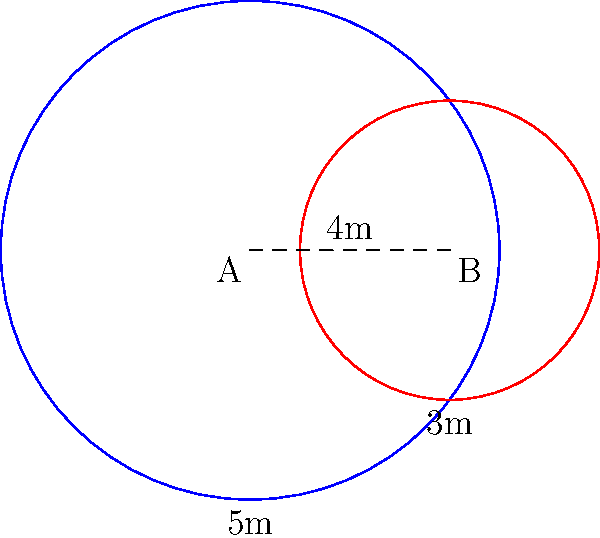During a spacewalk, two circular safety zones are established for different activities. Zone A has a radius of 5 meters, and Zone B has a radius of 3 meters. The centers of these zones are 4 meters apart. Calculate the area of the overlapping region between these two safety zones. Round your answer to two decimal places. To find the area of overlap between two circles, we can use the following steps:

1) First, we need to calculate the distance $d$ between the centers of the circles. We're given that $d = 4$ meters.

2) Let's denote the radii as $r_1 = 5$ m and $r_2 = 3$ m.

3) To find the area of overlap, we use the formula:

   $$A = r_1^2 \arccos(\frac{d^2 + r_1^2 - r_2^2}{2dr_1}) + r_2^2 \arccos(\frac{d^2 + r_2^2 - r_1^2}{2dr_2}) - \frac{1}{2}\sqrt{(-d+r_1+r_2)(d+r_1-r_2)(d-r_1+r_2)(d+r_1+r_2)}$$

4) Substituting our values:

   $$A = 5^2 \arccos(\frac{4^2 + 5^2 - 3^2}{2 \cdot 4 \cdot 5}) + 3^2 \arccos(\frac{4^2 + 3^2 - 5^2}{2 \cdot 4 \cdot 3}) - \frac{1}{2}\sqrt{(-4+5+3)(4+5-3)(4-5+3)(4+5+3)}$$

5) Simplifying:

   $$A = 25 \arccos(0.775) + 9 \arccos(-0.0833) - \frac{1}{2}\sqrt{4 \cdot 6 \cdot 2 \cdot 12}$$

6) Calculating:

   $$A = 25 \cdot 0.6935 + 9 \cdot 1.6542 - \frac{1}{2}\sqrt{576}$$
   $$A = 17.3375 + 14.8878 - 12$$
   $$A = 20.2253$$

7) Rounding to two decimal places: 20.23 square meters.
Answer: 20.23 square meters 